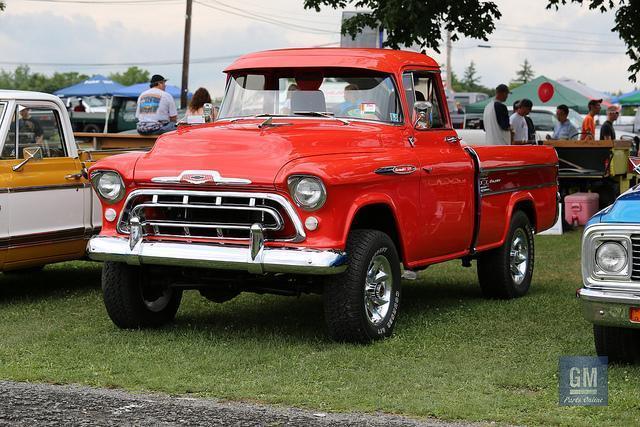How many tires can be seen in this picture?
Give a very brief answer. 4. How many trucks are in the photo?
Give a very brief answer. 3. 